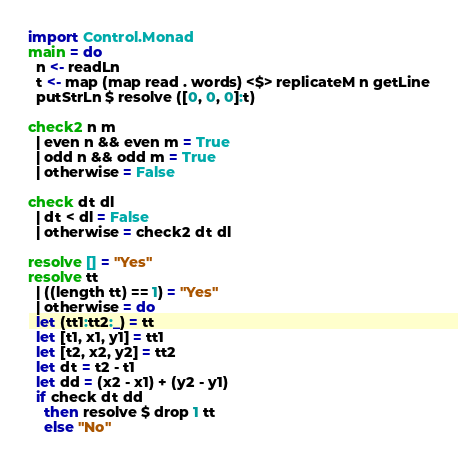<code> <loc_0><loc_0><loc_500><loc_500><_Haskell_>import Control.Monad
main = do
  n <- readLn
  t <- map (map read . words) <$> replicateM n getLine
  putStrLn $ resolve ([0, 0, 0]:t)

check2 n m
  | even n && even m = True
  | odd n && odd m = True
  | otherwise = False

check dt dl
  | dt < dl = False
  | otherwise = check2 dt dl

resolve [] = "Yes"
resolve tt
  | ((length tt) == 1) = "Yes"
  | otherwise = do
  let (tt1:tt2:_) = tt
  let [t1, x1, y1] = tt1
  let [t2, x2, y2] = tt2
  let dt = t2 - t1
  let dd = (x2 - x1) + (y2 - y1)
  if check dt dd
    then resolve $ drop 1 tt
    else "No"
</code> 